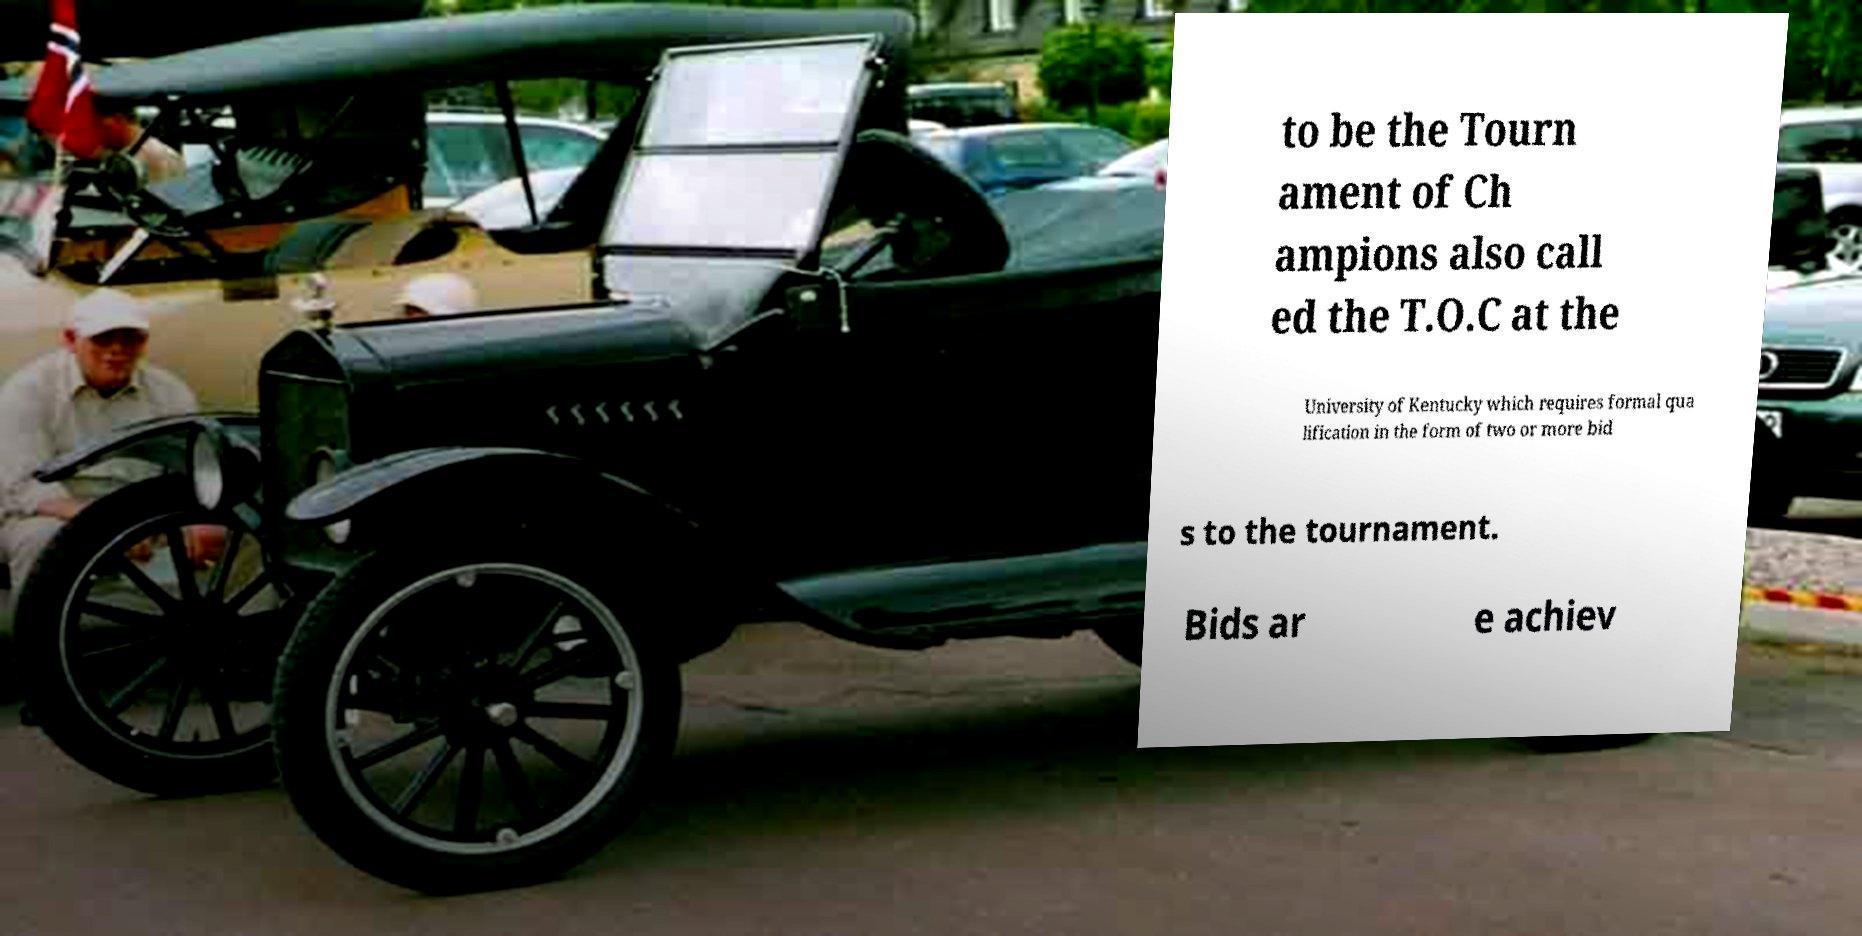There's text embedded in this image that I need extracted. Can you transcribe it verbatim? to be the Tourn ament of Ch ampions also call ed the T.O.C at the University of Kentucky which requires formal qua lification in the form of two or more bid s to the tournament. Bids ar e achiev 